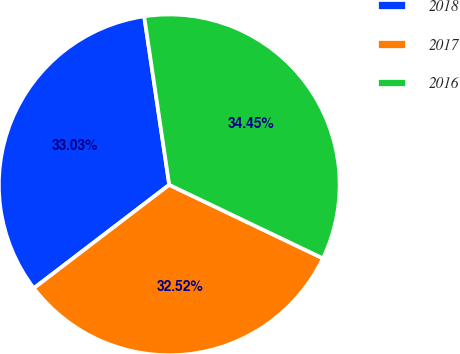Convert chart to OTSL. <chart><loc_0><loc_0><loc_500><loc_500><pie_chart><fcel>2018<fcel>2017<fcel>2016<nl><fcel>33.03%<fcel>32.52%<fcel>34.45%<nl></chart> 